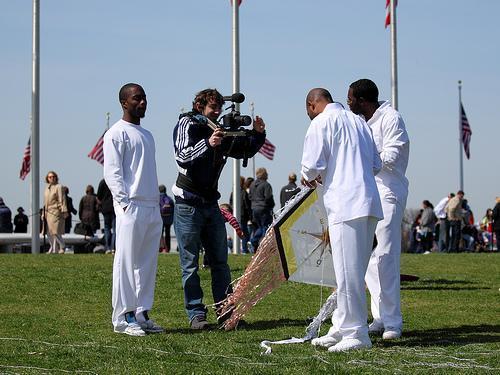How many flags are visible?
Give a very brief answer. 5. 